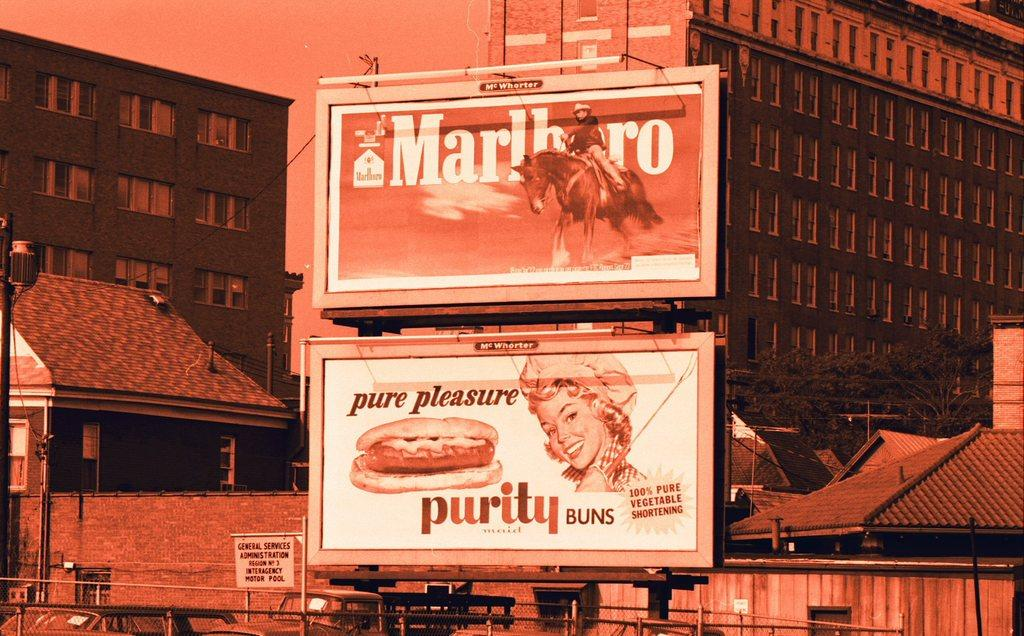<image>
Relay a brief, clear account of the picture shown. A washed out image of billboards featuring one for Marlboro and one for purity buns. 